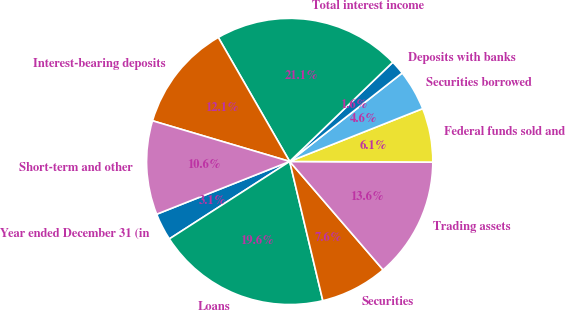Convert chart to OTSL. <chart><loc_0><loc_0><loc_500><loc_500><pie_chart><fcel>Year ended December 31 (in<fcel>Loans<fcel>Securities<fcel>Trading assets<fcel>Federal funds sold and<fcel>Securities borrowed<fcel>Deposits with banks<fcel>Total interest income<fcel>Interest-bearing deposits<fcel>Short-term and other<nl><fcel>3.09%<fcel>19.62%<fcel>7.6%<fcel>13.61%<fcel>6.09%<fcel>4.59%<fcel>1.59%<fcel>21.12%<fcel>12.1%<fcel>10.6%<nl></chart> 